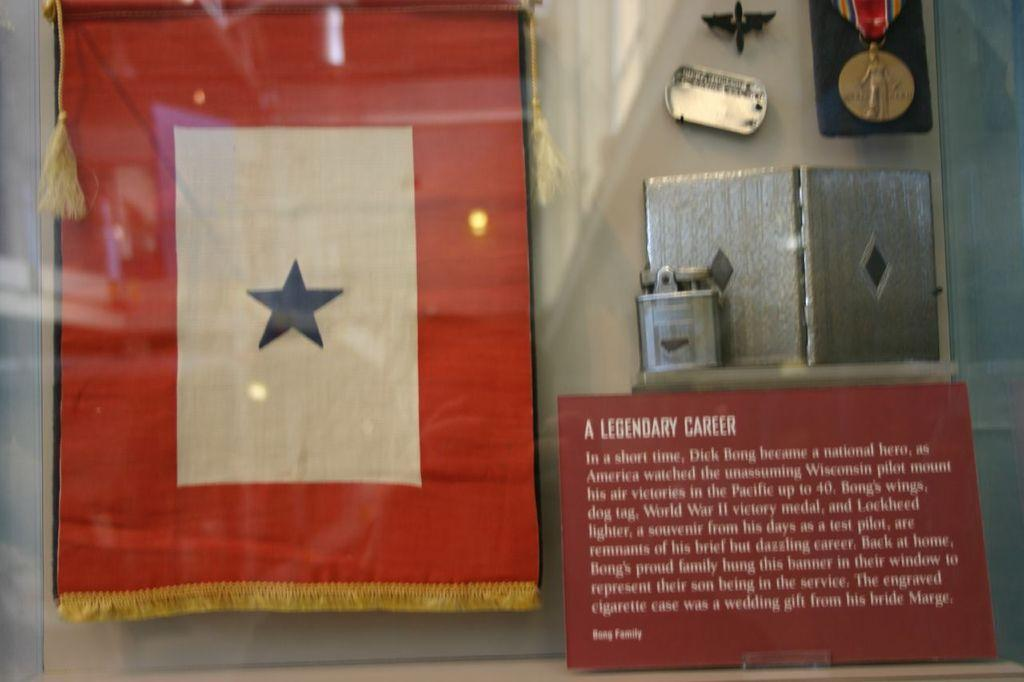What is the main object in the image? There is a glass in the image. What can be seen through the glass? Cloth is visible through the glass, as well as other objects. What is the board used for in the image? The purpose of the board in the image is not specified, but it is present. What are the batches used for in the image? The purpose of the batches in the image is not specified, but they are present. What can be observed on the surface of the glass? Light reflections are visible on the glass. What type of pancake is being prepared on the love in the image? There is no pancake or love present in the image; it features a glass with light reflections and other objects visible through it. 